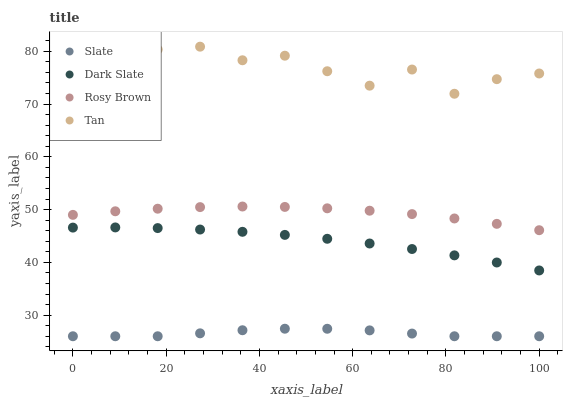Does Slate have the minimum area under the curve?
Answer yes or no. Yes. Does Tan have the maximum area under the curve?
Answer yes or no. Yes. Does Rosy Brown have the minimum area under the curve?
Answer yes or no. No. Does Rosy Brown have the maximum area under the curve?
Answer yes or no. No. Is Dark Slate the smoothest?
Answer yes or no. Yes. Is Tan the roughest?
Answer yes or no. Yes. Is Slate the smoothest?
Answer yes or no. No. Is Slate the roughest?
Answer yes or no. No. Does Slate have the lowest value?
Answer yes or no. Yes. Does Rosy Brown have the lowest value?
Answer yes or no. No. Does Tan have the highest value?
Answer yes or no. Yes. Does Rosy Brown have the highest value?
Answer yes or no. No. Is Rosy Brown less than Tan?
Answer yes or no. Yes. Is Dark Slate greater than Slate?
Answer yes or no. Yes. Does Rosy Brown intersect Tan?
Answer yes or no. No. 